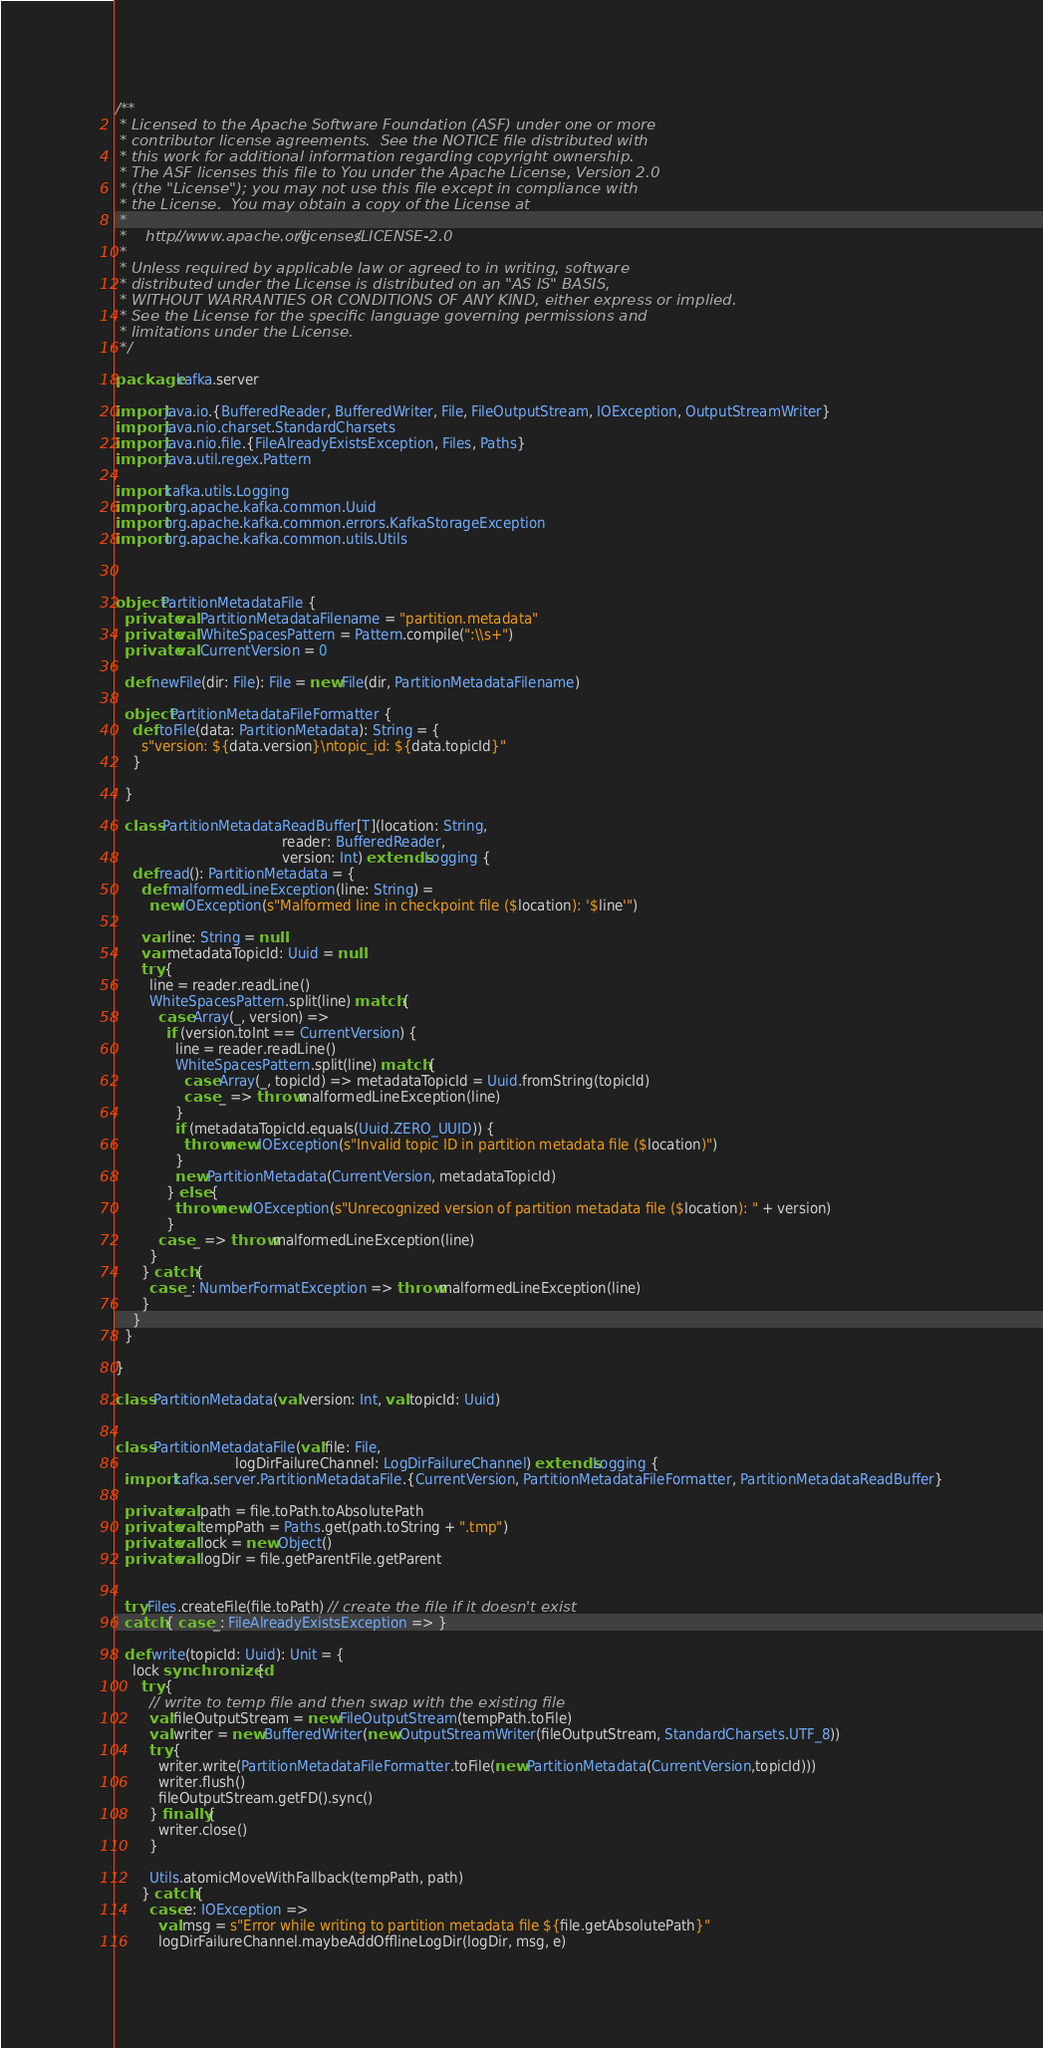<code> <loc_0><loc_0><loc_500><loc_500><_Scala_>/**
 * Licensed to the Apache Software Foundation (ASF) under one or more
 * contributor license agreements.  See the NOTICE file distributed with
 * this work for additional information regarding copyright ownership.
 * The ASF licenses this file to You under the Apache License, Version 2.0
 * (the "License"); you may not use this file except in compliance with
 * the License.  You may obtain a copy of the License at
 *
 *    http://www.apache.org/licenses/LICENSE-2.0
 *
 * Unless required by applicable law or agreed to in writing, software
 * distributed under the License is distributed on an "AS IS" BASIS,
 * WITHOUT WARRANTIES OR CONDITIONS OF ANY KIND, either express or implied.
 * See the License for the specific language governing permissions and
 * limitations under the License.
 */

package kafka.server

import java.io.{BufferedReader, BufferedWriter, File, FileOutputStream, IOException, OutputStreamWriter}
import java.nio.charset.StandardCharsets
import java.nio.file.{FileAlreadyExistsException, Files, Paths}
import java.util.regex.Pattern

import kafka.utils.Logging
import org.apache.kafka.common.Uuid
import org.apache.kafka.common.errors.KafkaStorageException
import org.apache.kafka.common.utils.Utils



object PartitionMetadataFile {
  private val PartitionMetadataFilename = "partition.metadata"
  private val WhiteSpacesPattern = Pattern.compile(":\\s+")
  private val CurrentVersion = 0

  def newFile(dir: File): File = new File(dir, PartitionMetadataFilename)

  object PartitionMetadataFileFormatter {
    def toFile(data: PartitionMetadata): String = {
      s"version: ${data.version}\ntopic_id: ${data.topicId}"
    }

  }

  class PartitionMetadataReadBuffer[T](location: String,
                                       reader: BufferedReader,
                                       version: Int) extends Logging {
    def read(): PartitionMetadata = {
      def malformedLineException(line: String) =
        new IOException(s"Malformed line in checkpoint file ($location): '$line'")

      var line: String = null
      var metadataTopicId: Uuid = null
      try {
        line = reader.readLine()
        WhiteSpacesPattern.split(line) match {
          case Array(_, version) =>
            if (version.toInt == CurrentVersion) {
              line = reader.readLine()
              WhiteSpacesPattern.split(line) match {
                case Array(_, topicId) => metadataTopicId = Uuid.fromString(topicId)
                case _ => throw malformedLineException(line)
              }
              if (metadataTopicId.equals(Uuid.ZERO_UUID)) {
                throw new IOException(s"Invalid topic ID in partition metadata file ($location)")
              }
              new PartitionMetadata(CurrentVersion, metadataTopicId)
            } else {
              throw new IOException(s"Unrecognized version of partition metadata file ($location): " + version)
            }
          case _ => throw malformedLineException(line)
        }
      } catch {
        case _: NumberFormatException => throw malformedLineException(line)
      }
    }
  }

}

class PartitionMetadata(val version: Int, val topicId: Uuid)


class PartitionMetadataFile(val file: File,
                            logDirFailureChannel: LogDirFailureChannel) extends Logging {
  import kafka.server.PartitionMetadataFile.{CurrentVersion, PartitionMetadataFileFormatter, PartitionMetadataReadBuffer}

  private val path = file.toPath.toAbsolutePath
  private val tempPath = Paths.get(path.toString + ".tmp")
  private val lock = new Object()
  private val logDir = file.getParentFile.getParent


  try Files.createFile(file.toPath) // create the file if it doesn't exist
  catch { case _: FileAlreadyExistsException => }

  def write(topicId: Uuid): Unit = {
    lock synchronized {
      try {
        // write to temp file and then swap with the existing file
        val fileOutputStream = new FileOutputStream(tempPath.toFile)
        val writer = new BufferedWriter(new OutputStreamWriter(fileOutputStream, StandardCharsets.UTF_8))
        try {
          writer.write(PartitionMetadataFileFormatter.toFile(new PartitionMetadata(CurrentVersion,topicId)))
          writer.flush()
          fileOutputStream.getFD().sync()
        } finally {
          writer.close()
        }

        Utils.atomicMoveWithFallback(tempPath, path)
      } catch {
        case e: IOException =>
          val msg = s"Error while writing to partition metadata file ${file.getAbsolutePath}"
          logDirFailureChannel.maybeAddOfflineLogDir(logDir, msg, e)</code> 